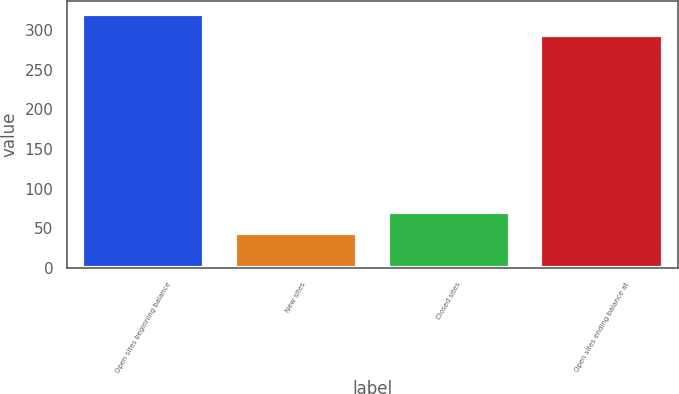Convert chart. <chart><loc_0><loc_0><loc_500><loc_500><bar_chart><fcel>Open sites beginning balance<fcel>New sites<fcel>Closed sites<fcel>Open sites ending balance at<nl><fcel>320.3<fcel>44<fcel>70.3<fcel>294<nl></chart> 